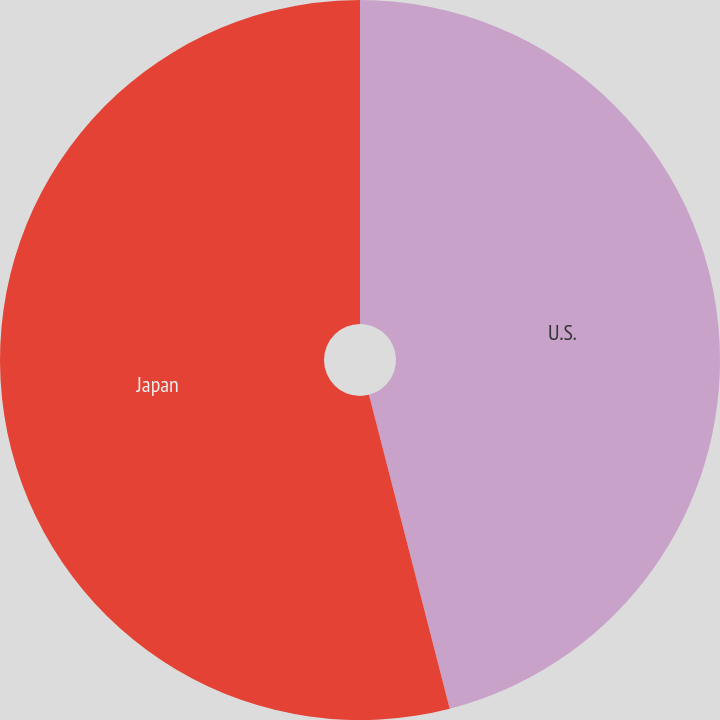Convert chart. <chart><loc_0><loc_0><loc_500><loc_500><pie_chart><fcel>U.S.<fcel>Japan<nl><fcel>45.99%<fcel>54.01%<nl></chart> 